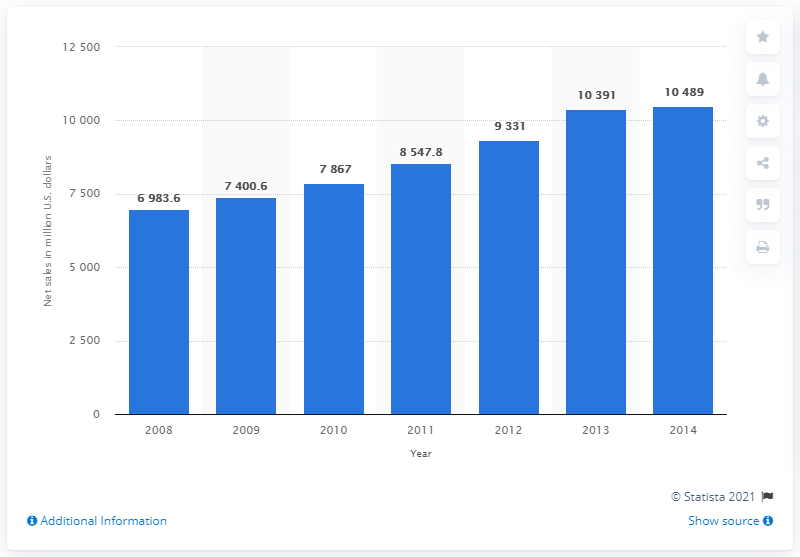Give some essential details in this illustration. In 2012, the net sales of Family Dollar in the United States were 9,331. 